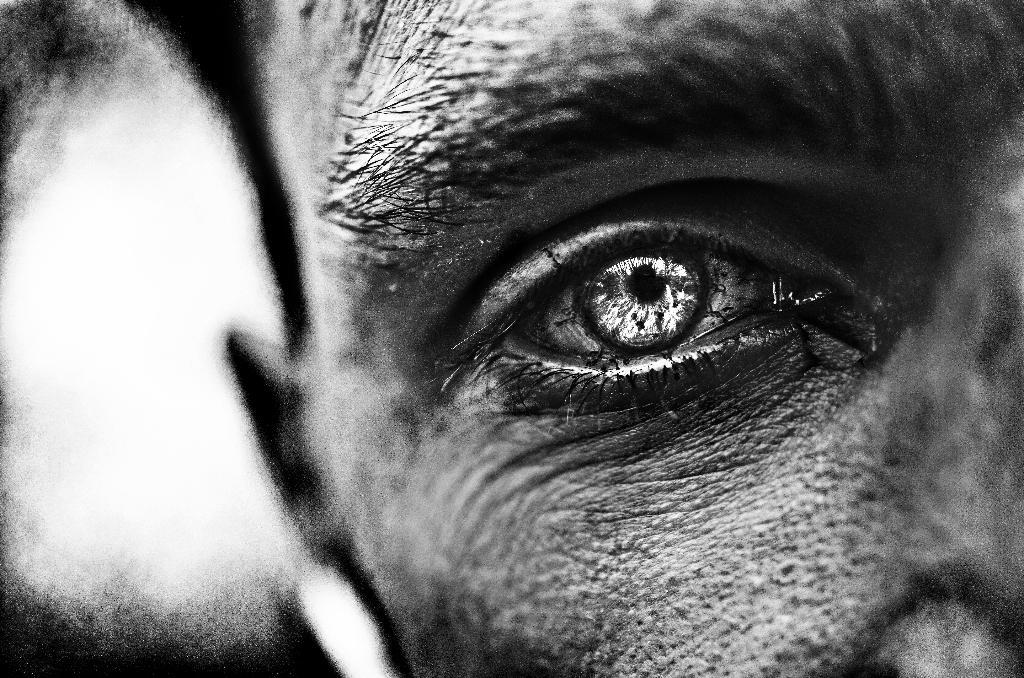Who is the main subject in the image? There is a man in the image. Can you describe the perspective of the image? The image is zoomed in. What part of the man's body is prominently featured in the image? The eye of the man is visible in the front of the image. What type of cakes can be seen in the image? There are no cakes present in the image. What kind of produce is visible in the image? There is no produce visible in the image. 